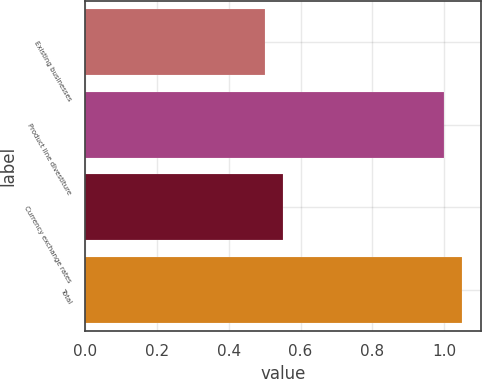Convert chart. <chart><loc_0><loc_0><loc_500><loc_500><bar_chart><fcel>Existing businesses<fcel>Product line divestiture<fcel>Currency exchange rates<fcel>Total<nl><fcel>0.5<fcel>1<fcel>0.55<fcel>1.05<nl></chart> 